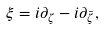<formula> <loc_0><loc_0><loc_500><loc_500>\xi = i \partial _ { \zeta } - i \partial _ { \bar { \zeta } } ,</formula> 